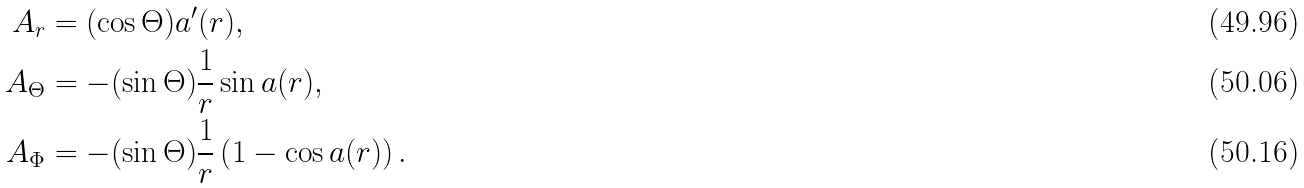Convert formula to latex. <formula><loc_0><loc_0><loc_500><loc_500>A _ { r } & = ( \cos \Theta ) a ^ { \prime } ( r ) , \\ A _ { \Theta } & = - ( \sin \Theta ) \frac { 1 } { r } \sin a ( r ) , \\ A _ { \Phi } & = - ( \sin \Theta ) \frac { 1 } { r } \left ( 1 - \cos a ( r ) \right ) .</formula> 